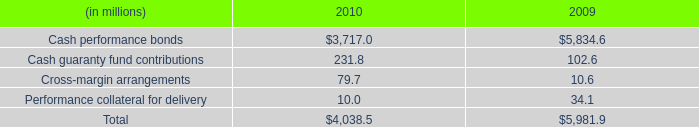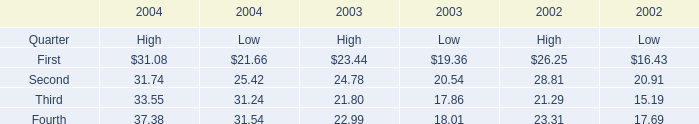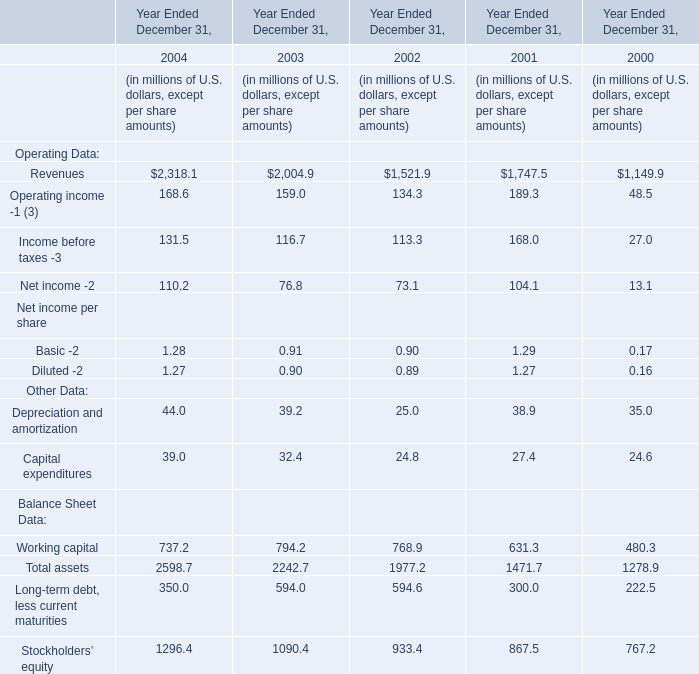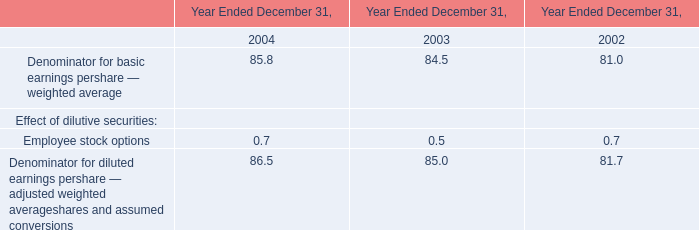for 2010 , what was the net deferred tax liability? 
Computations: (((7.8 * 1000000) * 1000) - (18.3 * 1000000))
Answer: 7781700000.0. 